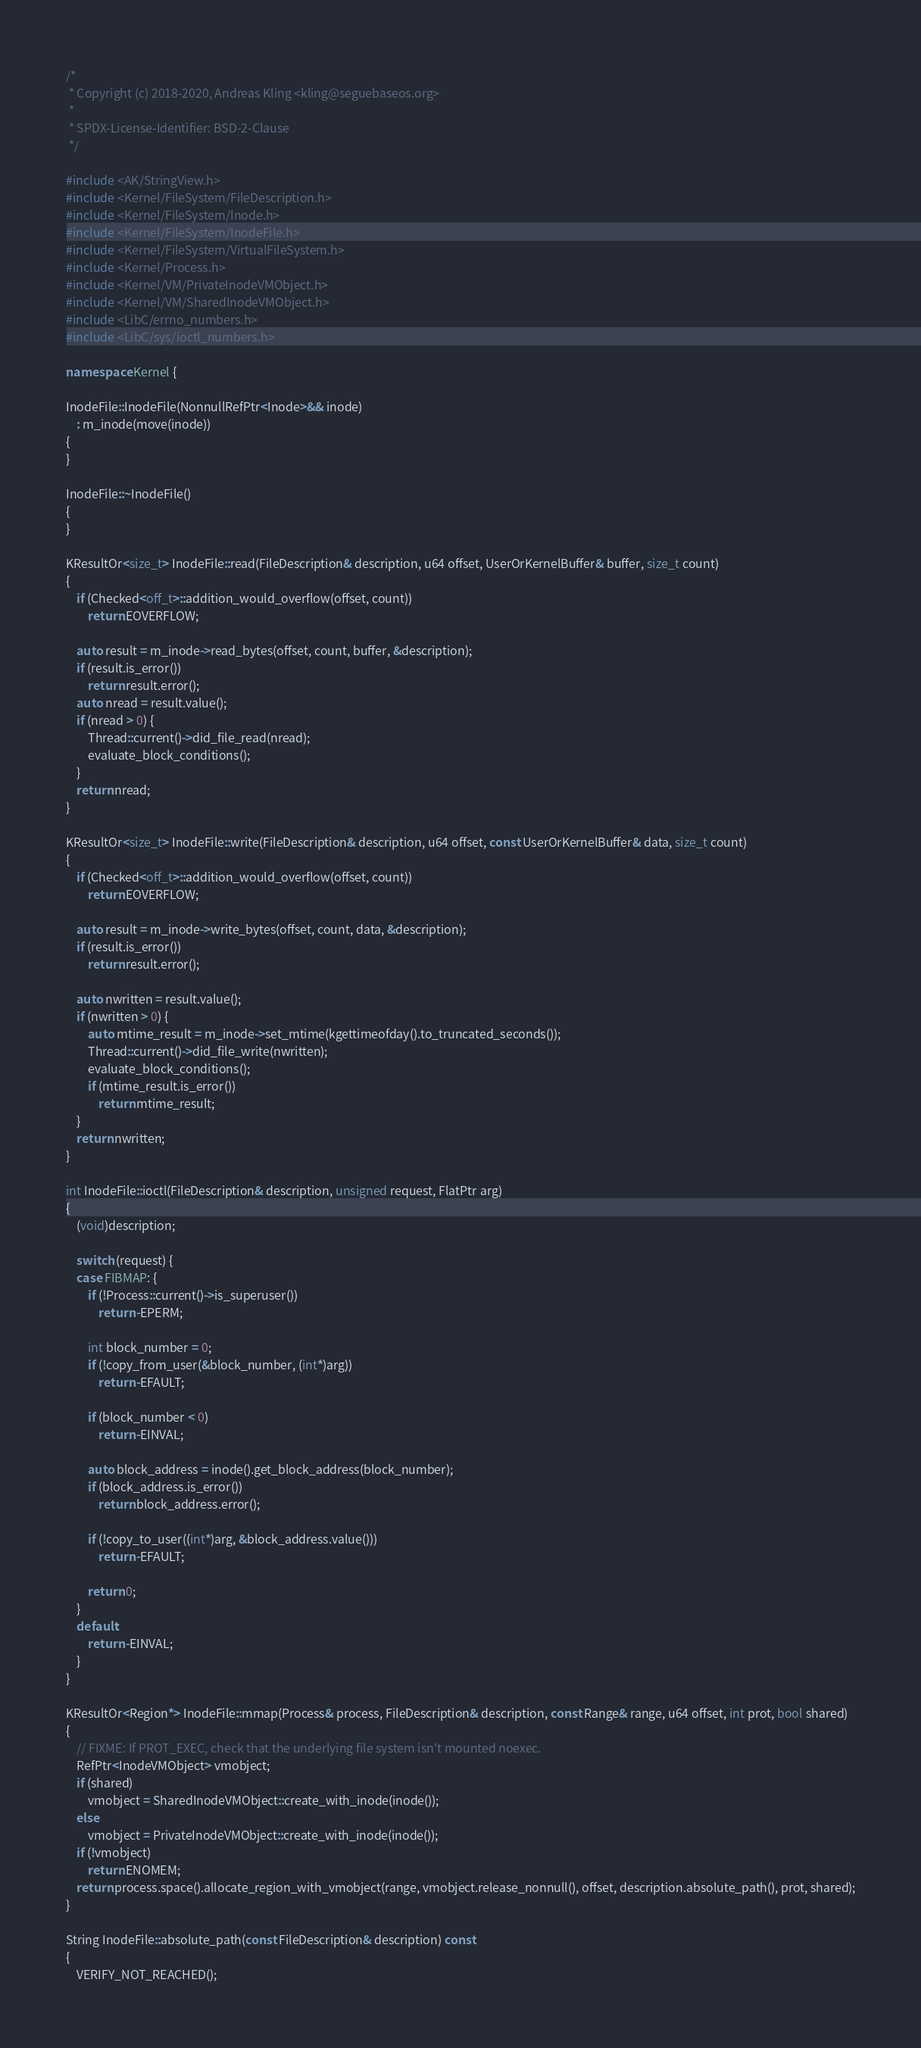Convert code to text. <code><loc_0><loc_0><loc_500><loc_500><_C++_>/*
 * Copyright (c) 2018-2020, Andreas Kling <kling@seguebaseos.org>
 *
 * SPDX-License-Identifier: BSD-2-Clause
 */

#include <AK/StringView.h>
#include <Kernel/FileSystem/FileDescription.h>
#include <Kernel/FileSystem/Inode.h>
#include <Kernel/FileSystem/InodeFile.h>
#include <Kernel/FileSystem/VirtualFileSystem.h>
#include <Kernel/Process.h>
#include <Kernel/VM/PrivateInodeVMObject.h>
#include <Kernel/VM/SharedInodeVMObject.h>
#include <LibC/errno_numbers.h>
#include <LibC/sys/ioctl_numbers.h>

namespace Kernel {

InodeFile::InodeFile(NonnullRefPtr<Inode>&& inode)
    : m_inode(move(inode))
{
}

InodeFile::~InodeFile()
{
}

KResultOr<size_t> InodeFile::read(FileDescription& description, u64 offset, UserOrKernelBuffer& buffer, size_t count)
{
    if (Checked<off_t>::addition_would_overflow(offset, count))
        return EOVERFLOW;

    auto result = m_inode->read_bytes(offset, count, buffer, &description);
    if (result.is_error())
        return result.error();
    auto nread = result.value();
    if (nread > 0) {
        Thread::current()->did_file_read(nread);
        evaluate_block_conditions();
    }
    return nread;
}

KResultOr<size_t> InodeFile::write(FileDescription& description, u64 offset, const UserOrKernelBuffer& data, size_t count)
{
    if (Checked<off_t>::addition_would_overflow(offset, count))
        return EOVERFLOW;

    auto result = m_inode->write_bytes(offset, count, data, &description);
    if (result.is_error())
        return result.error();

    auto nwritten = result.value();
    if (nwritten > 0) {
        auto mtime_result = m_inode->set_mtime(kgettimeofday().to_truncated_seconds());
        Thread::current()->did_file_write(nwritten);
        evaluate_block_conditions();
        if (mtime_result.is_error())
            return mtime_result;
    }
    return nwritten;
}

int InodeFile::ioctl(FileDescription& description, unsigned request, FlatPtr arg)
{
    (void)description;

    switch (request) {
    case FIBMAP: {
        if (!Process::current()->is_superuser())
            return -EPERM;

        int block_number = 0;
        if (!copy_from_user(&block_number, (int*)arg))
            return -EFAULT;

        if (block_number < 0)
            return -EINVAL;

        auto block_address = inode().get_block_address(block_number);
        if (block_address.is_error())
            return block_address.error();

        if (!copy_to_user((int*)arg, &block_address.value()))
            return -EFAULT;

        return 0;
    }
    default:
        return -EINVAL;
    }
}

KResultOr<Region*> InodeFile::mmap(Process& process, FileDescription& description, const Range& range, u64 offset, int prot, bool shared)
{
    // FIXME: If PROT_EXEC, check that the underlying file system isn't mounted noexec.
    RefPtr<InodeVMObject> vmobject;
    if (shared)
        vmobject = SharedInodeVMObject::create_with_inode(inode());
    else
        vmobject = PrivateInodeVMObject::create_with_inode(inode());
    if (!vmobject)
        return ENOMEM;
    return process.space().allocate_region_with_vmobject(range, vmobject.release_nonnull(), offset, description.absolute_path(), prot, shared);
}

String InodeFile::absolute_path(const FileDescription& description) const
{
    VERIFY_NOT_REACHED();</code> 